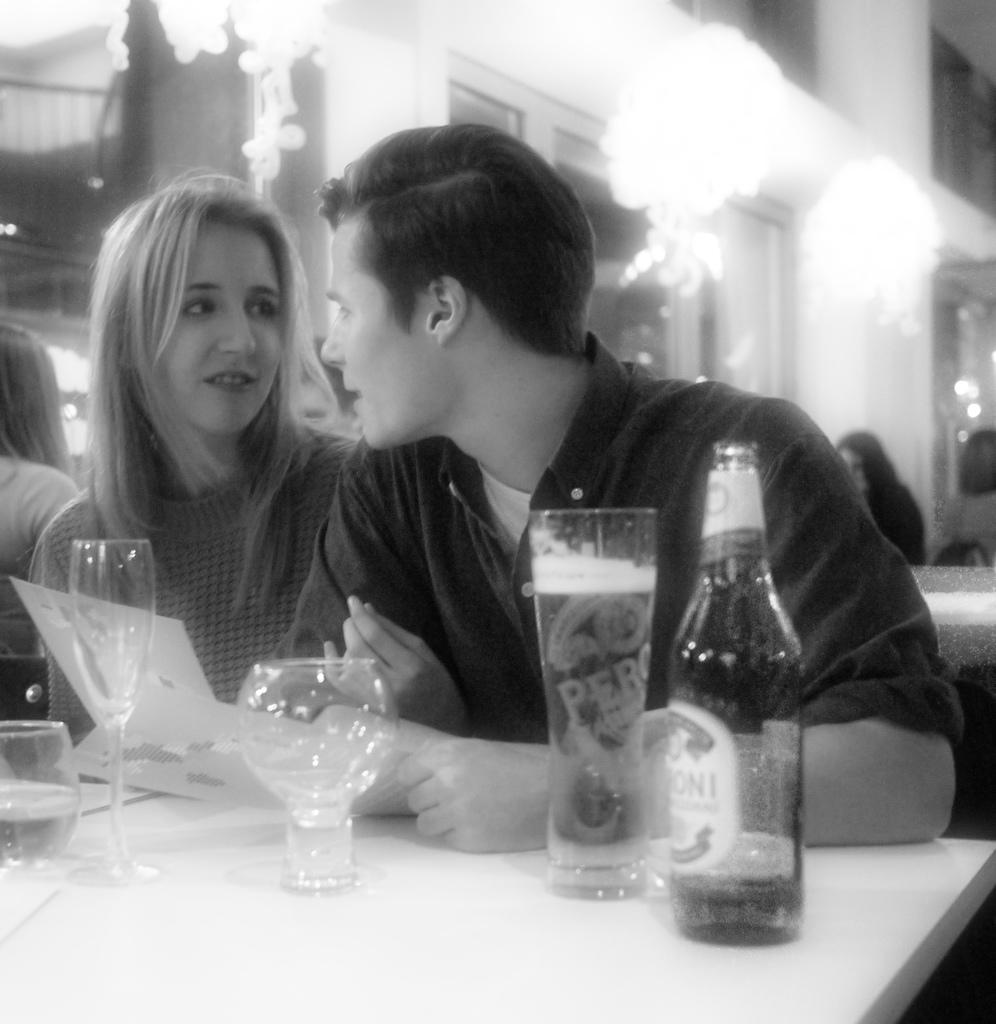How many people are present in the image? There are two people, a woman and a man, present in the image. What are the woman and man doing in the image? The woman and man are sitting. What is on the table in the image? There are 4 glasses and a bottle on the table. What can be seen in the background of the image? There are people and lights visible in the background. What type of fiction is the woman reading in the image? There is no book or any indication of reading in the image, so it cannot be determined if the woman is reading fiction or any other type of material. 